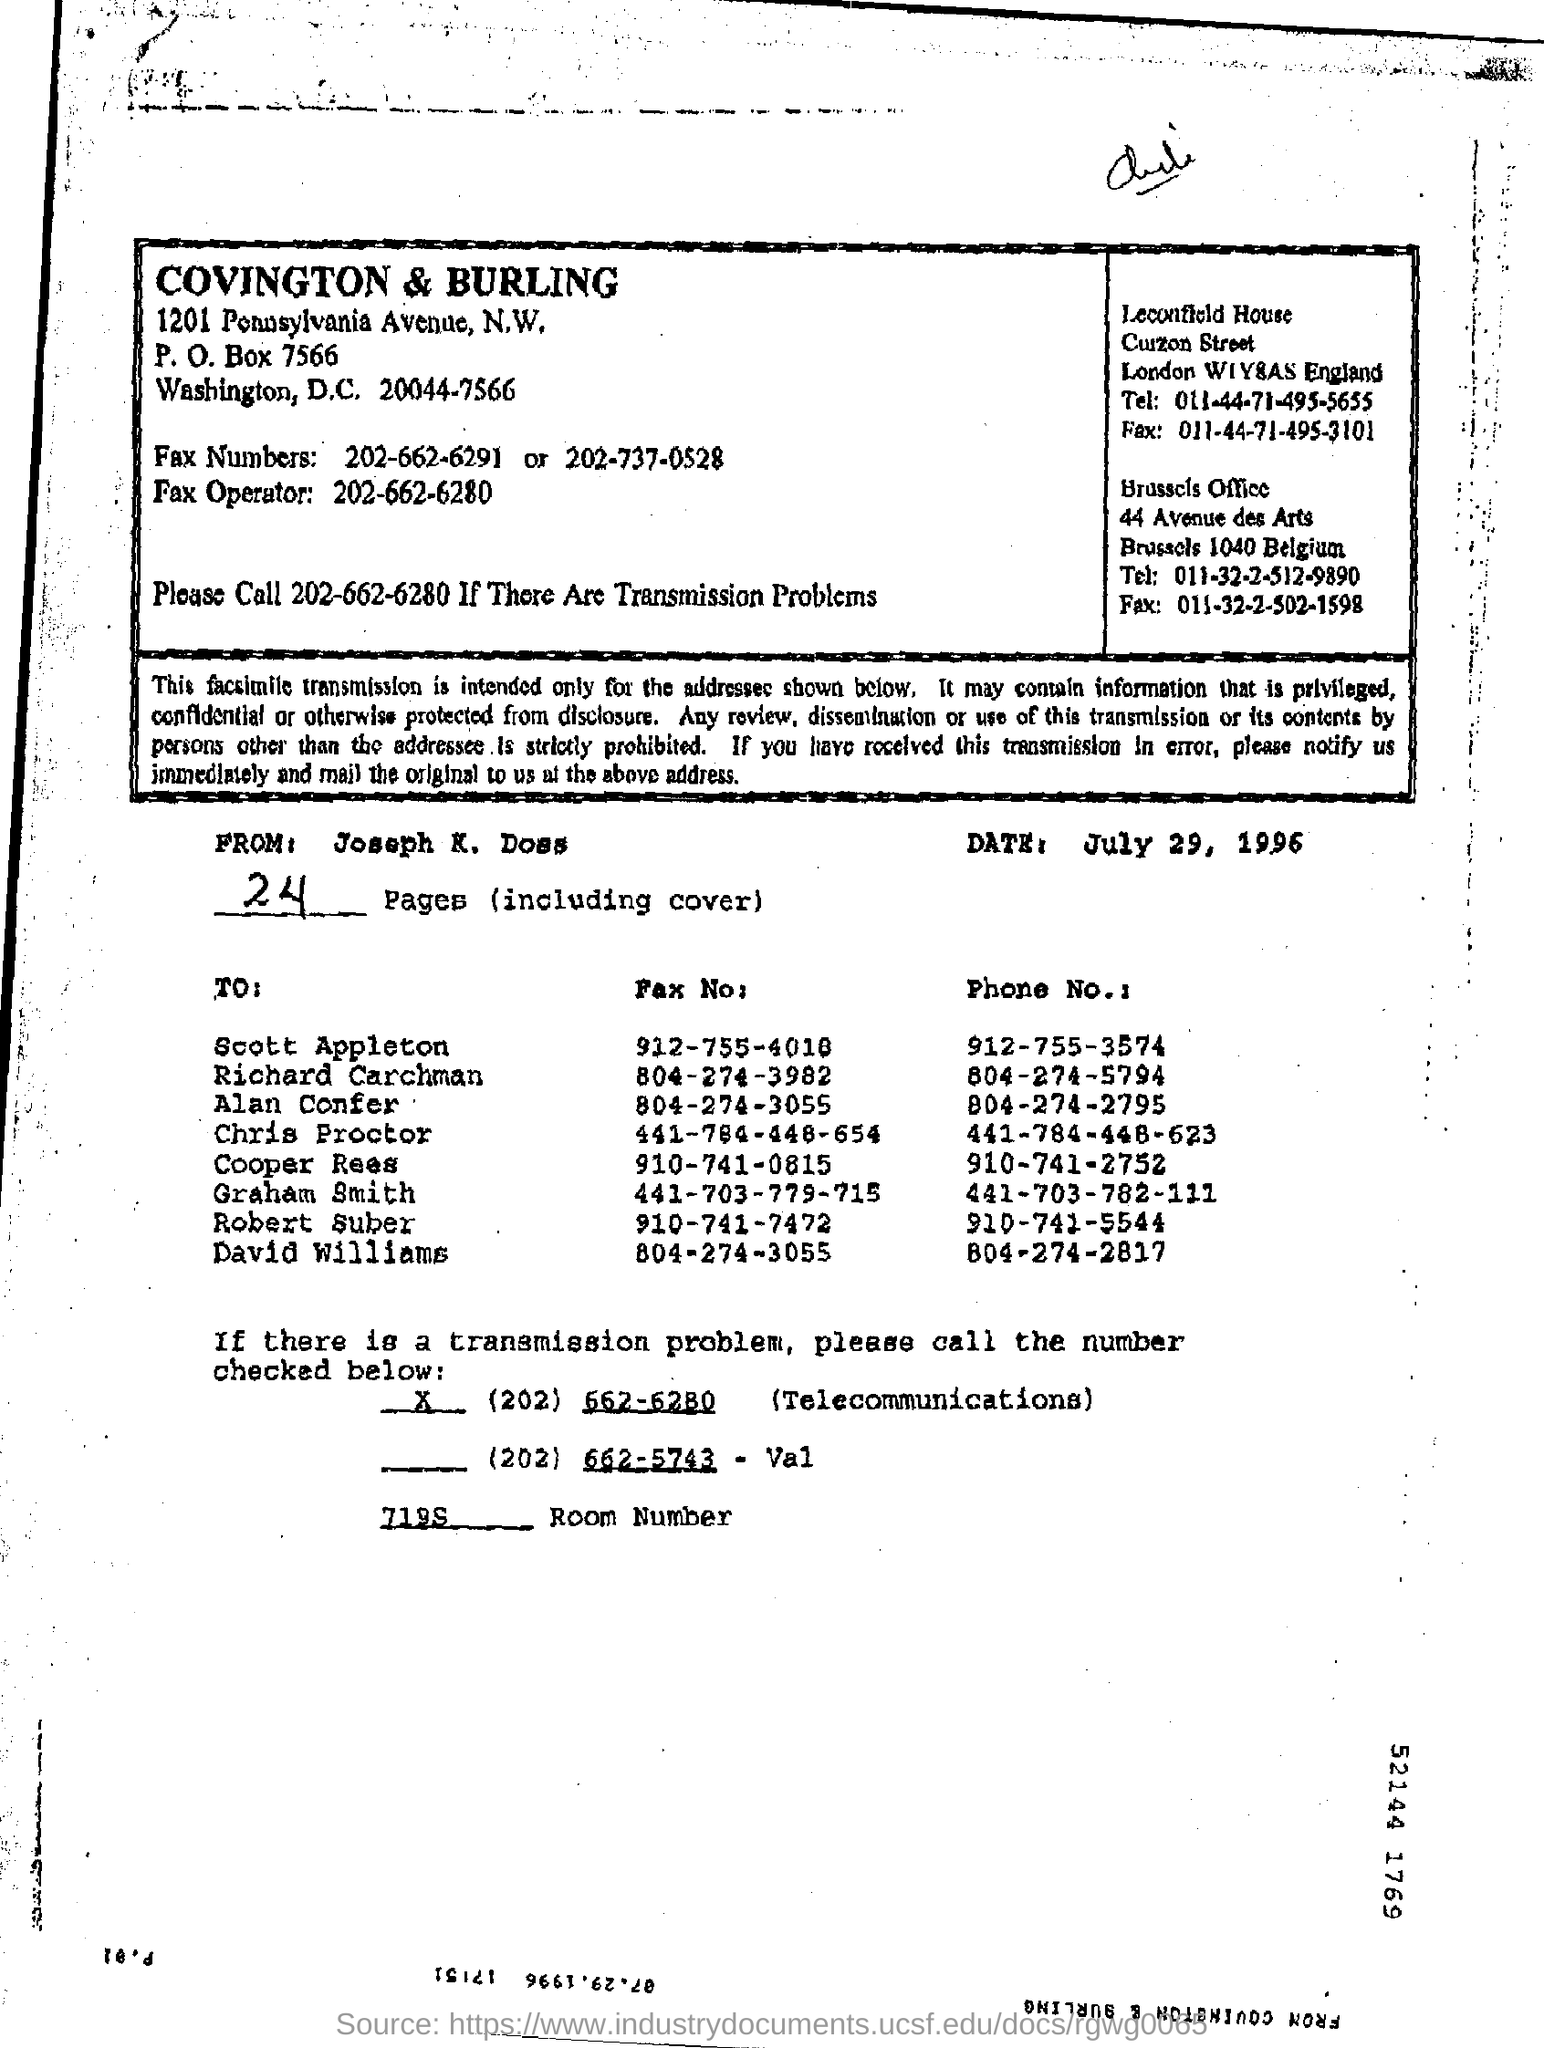What is the post box number  of COBNVINGTON & BURLING
Your answer should be compact. 7566. What is the date in the document?
Ensure brevity in your answer.  July 29, 1996. What is the phone number of the graham smith ?
Your answer should be very brief. 441-703-782-111. What is the number of the room?
Offer a very short reply. 7195. In which avenue brussels office is there?
Your answer should be compact. 44 Avenue des Arts. What is the telephone number of the Brussels office?
Give a very brief answer. 011-32-2-512-9890. 